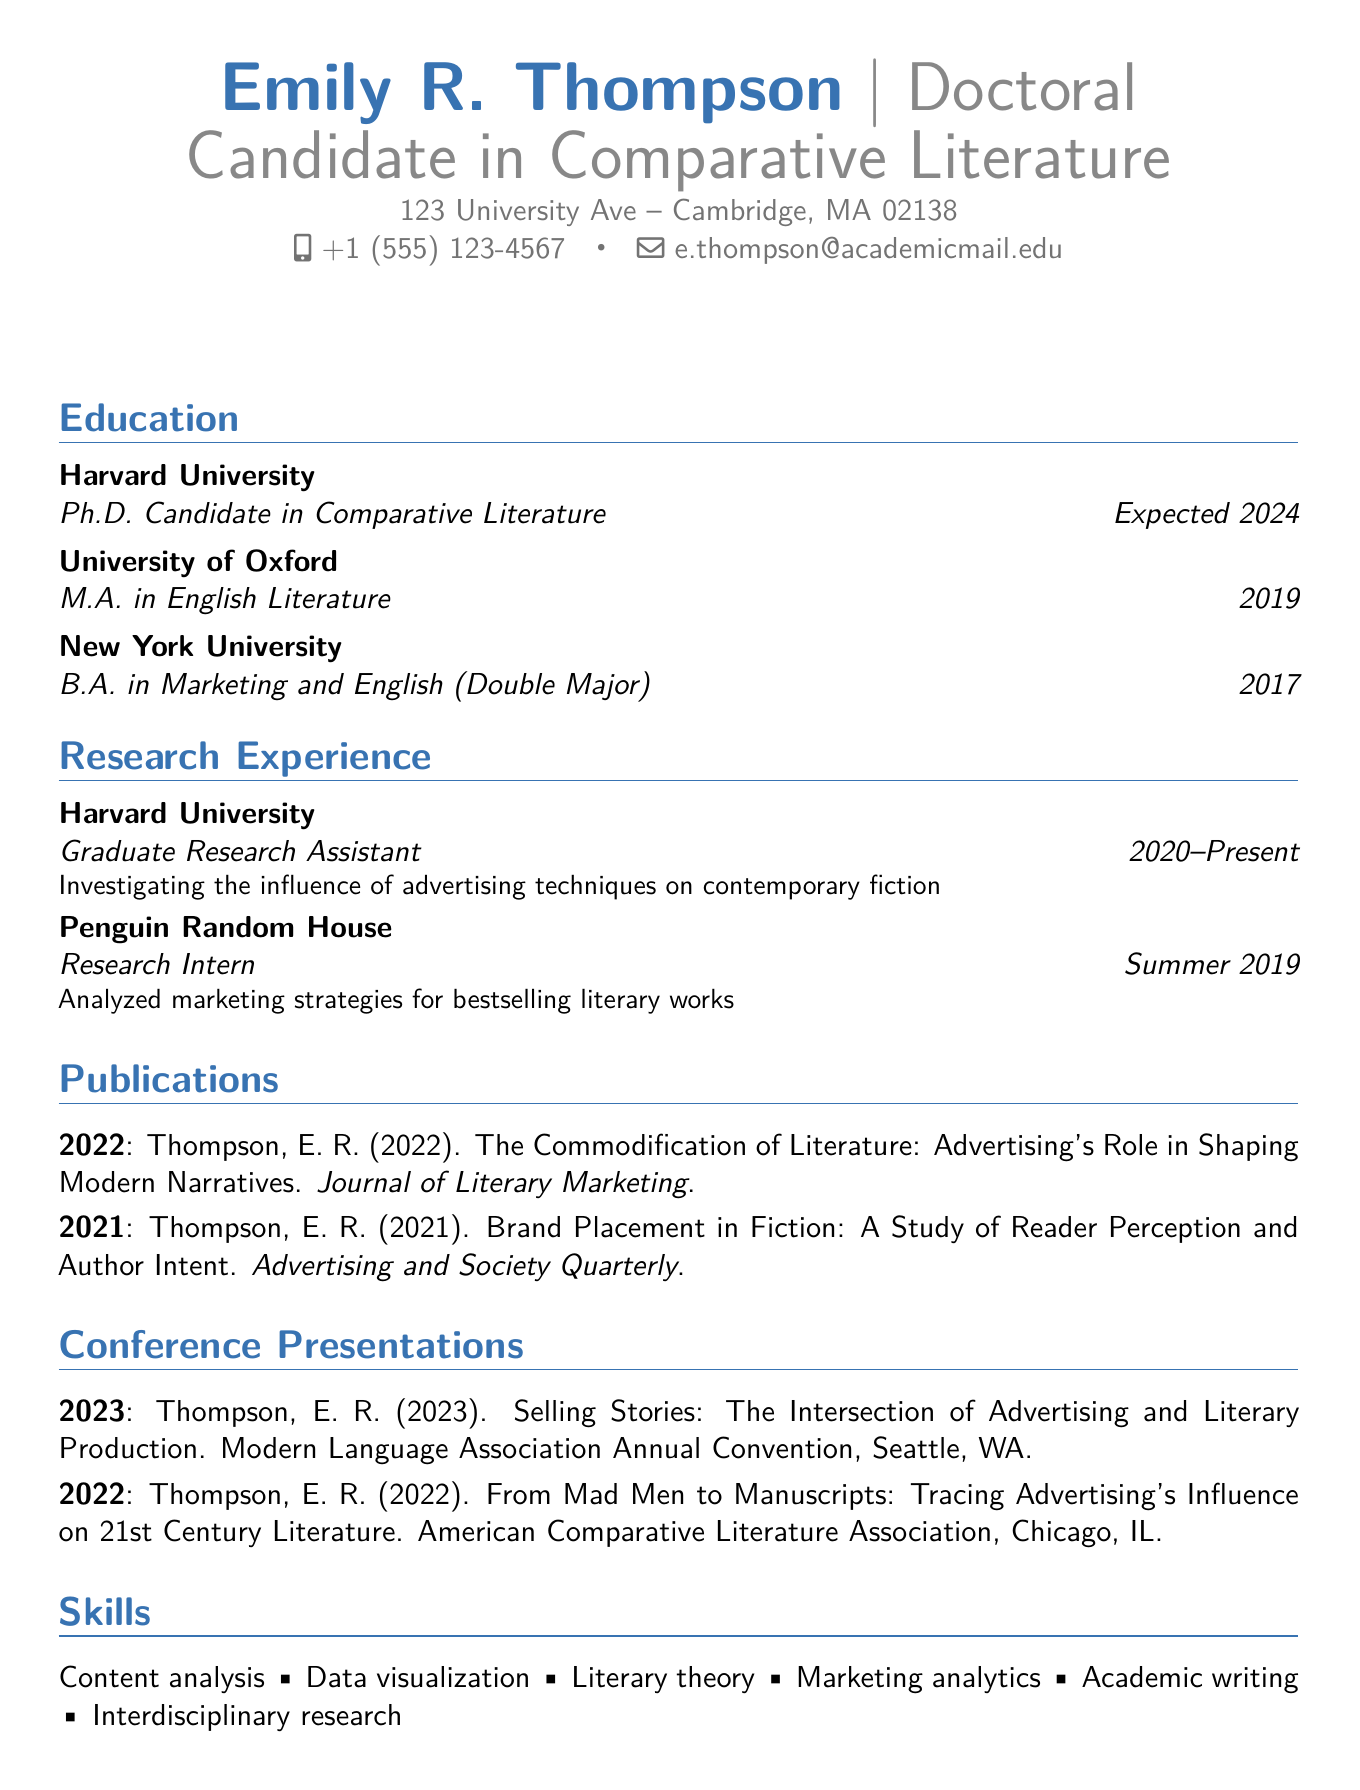What is the name of the candidate? The name of the candidate is listed at the top of the document.
Answer: Emily R. Thompson What is the highest degree obtained by the candidate? The highest degree mentioned is the most recent educational qualification.
Answer: Ph.D. Candidate in Comparative Literature What publication year is associated with the article on commodification? The year of publication is specified next to the article title.
Answer: 2022 In which conference was the presentation titled "Selling Stories" given? The conference name is provided along with the presentation title in the document.
Answer: Modern Language Association Annual Convention How long has the candidate been a Graduate Research Assistant? The duration is stated in the research experience section.
Answer: 2020-Present What is one of the candidate's skills listed in the CV? The skills section enumerates several abilities.
Answer: Content analysis What institution did the candidate complete their M.A. at? The institution for the master's degree is included in the education section.
Answer: University of Oxford What language is spoken fluently by the candidate? The language proficiency section lists the candidate's language capabilities.
Answer: French How many publications are listed in the document? The total number of publications can be counted from the publications section.
Answer: 2 